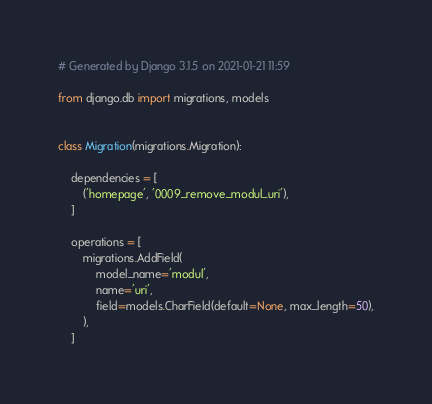<code> <loc_0><loc_0><loc_500><loc_500><_Python_># Generated by Django 3.1.5 on 2021-01-21 11:59

from django.db import migrations, models


class Migration(migrations.Migration):

    dependencies = [
        ('homepage', '0009_remove_modul_uri'),
    ]

    operations = [
        migrations.AddField(
            model_name='modul',
            name='uri',
            field=models.CharField(default=None, max_length=50),
        ),
    ]
</code> 